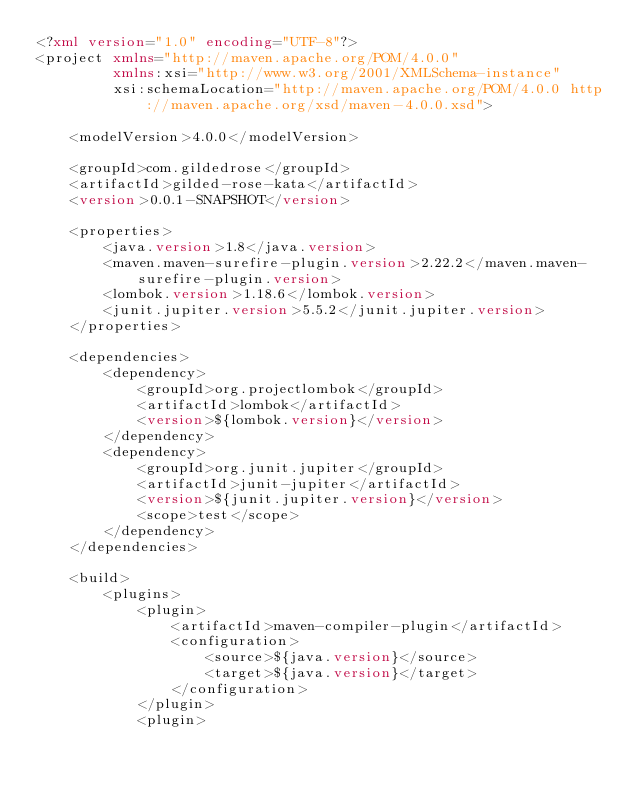Convert code to text. <code><loc_0><loc_0><loc_500><loc_500><_XML_><?xml version="1.0" encoding="UTF-8"?>
<project xmlns="http://maven.apache.org/POM/4.0.0"
         xmlns:xsi="http://www.w3.org/2001/XMLSchema-instance"
         xsi:schemaLocation="http://maven.apache.org/POM/4.0.0 http://maven.apache.org/xsd/maven-4.0.0.xsd">

    <modelVersion>4.0.0</modelVersion>

    <groupId>com.gildedrose</groupId>
    <artifactId>gilded-rose-kata</artifactId>
    <version>0.0.1-SNAPSHOT</version>

    <properties>
        <java.version>1.8</java.version>
        <maven.maven-surefire-plugin.version>2.22.2</maven.maven-surefire-plugin.version>
        <lombok.version>1.18.6</lombok.version>
        <junit.jupiter.version>5.5.2</junit.jupiter.version>
    </properties>

    <dependencies>
        <dependency>
            <groupId>org.projectlombok</groupId>
            <artifactId>lombok</artifactId>
            <version>${lombok.version}</version>
        </dependency>
        <dependency>
            <groupId>org.junit.jupiter</groupId>
            <artifactId>junit-jupiter</artifactId>
            <version>${junit.jupiter.version}</version>
            <scope>test</scope>
        </dependency>
    </dependencies>

    <build>
        <plugins>
            <plugin>
                <artifactId>maven-compiler-plugin</artifactId>
                <configuration>
                    <source>${java.version}</source>
                    <target>${java.version}</target>
                </configuration>
            </plugin>
            <plugin></code> 